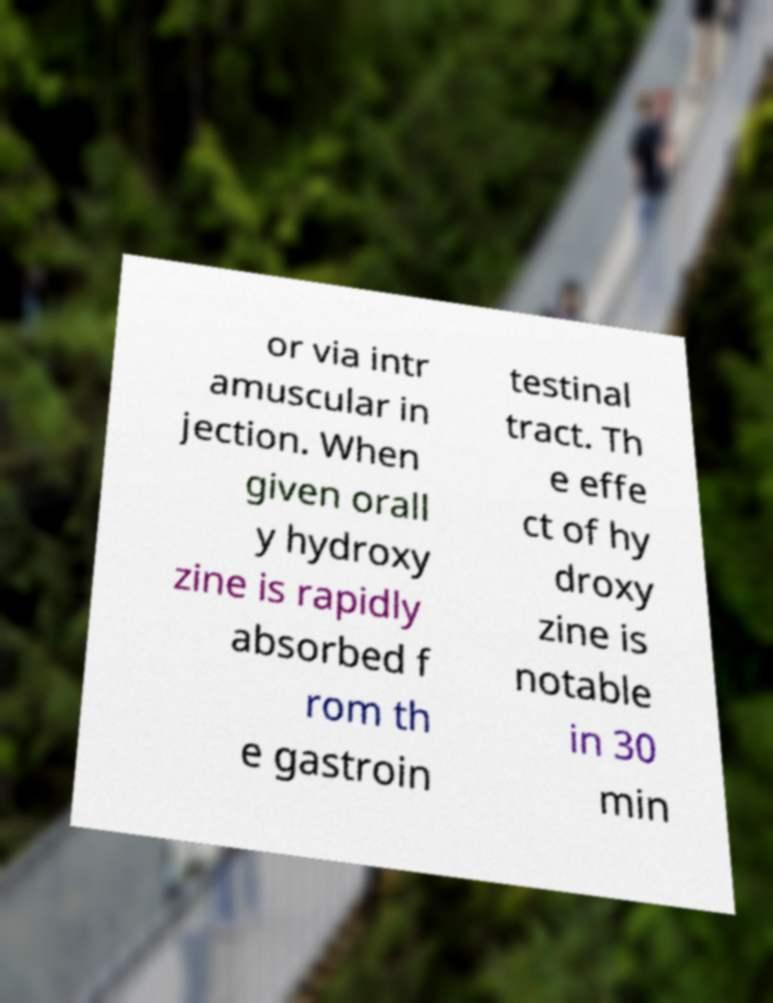I need the written content from this picture converted into text. Can you do that? or via intr amuscular in jection. When given orall y hydroxy zine is rapidly absorbed f rom th e gastroin testinal tract. Th e effe ct of hy droxy zine is notable in 30 min 